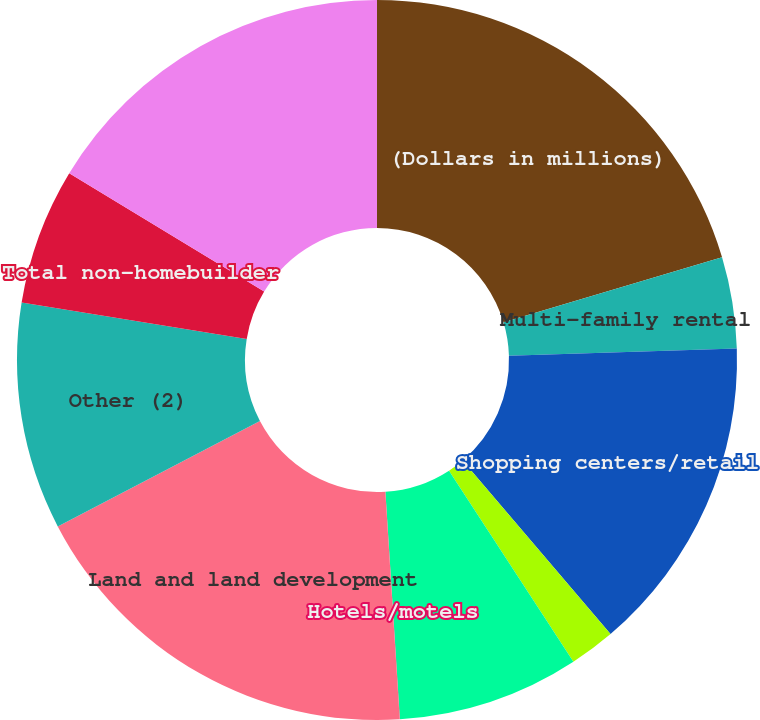Convert chart to OTSL. <chart><loc_0><loc_0><loc_500><loc_500><pie_chart><fcel>(Dollars in millions)<fcel>Multi-family rental<fcel>Shopping centers/retail<fcel>Industrial/warehouse<fcel>Multi-use<fcel>Hotels/motels<fcel>Land and land development<fcel>Other (2)<fcel>Total non-homebuilder<fcel>Commercial real estate -<nl><fcel>20.4%<fcel>4.09%<fcel>14.28%<fcel>2.05%<fcel>8.17%<fcel>0.01%<fcel>18.36%<fcel>10.2%<fcel>6.13%<fcel>16.32%<nl></chart> 